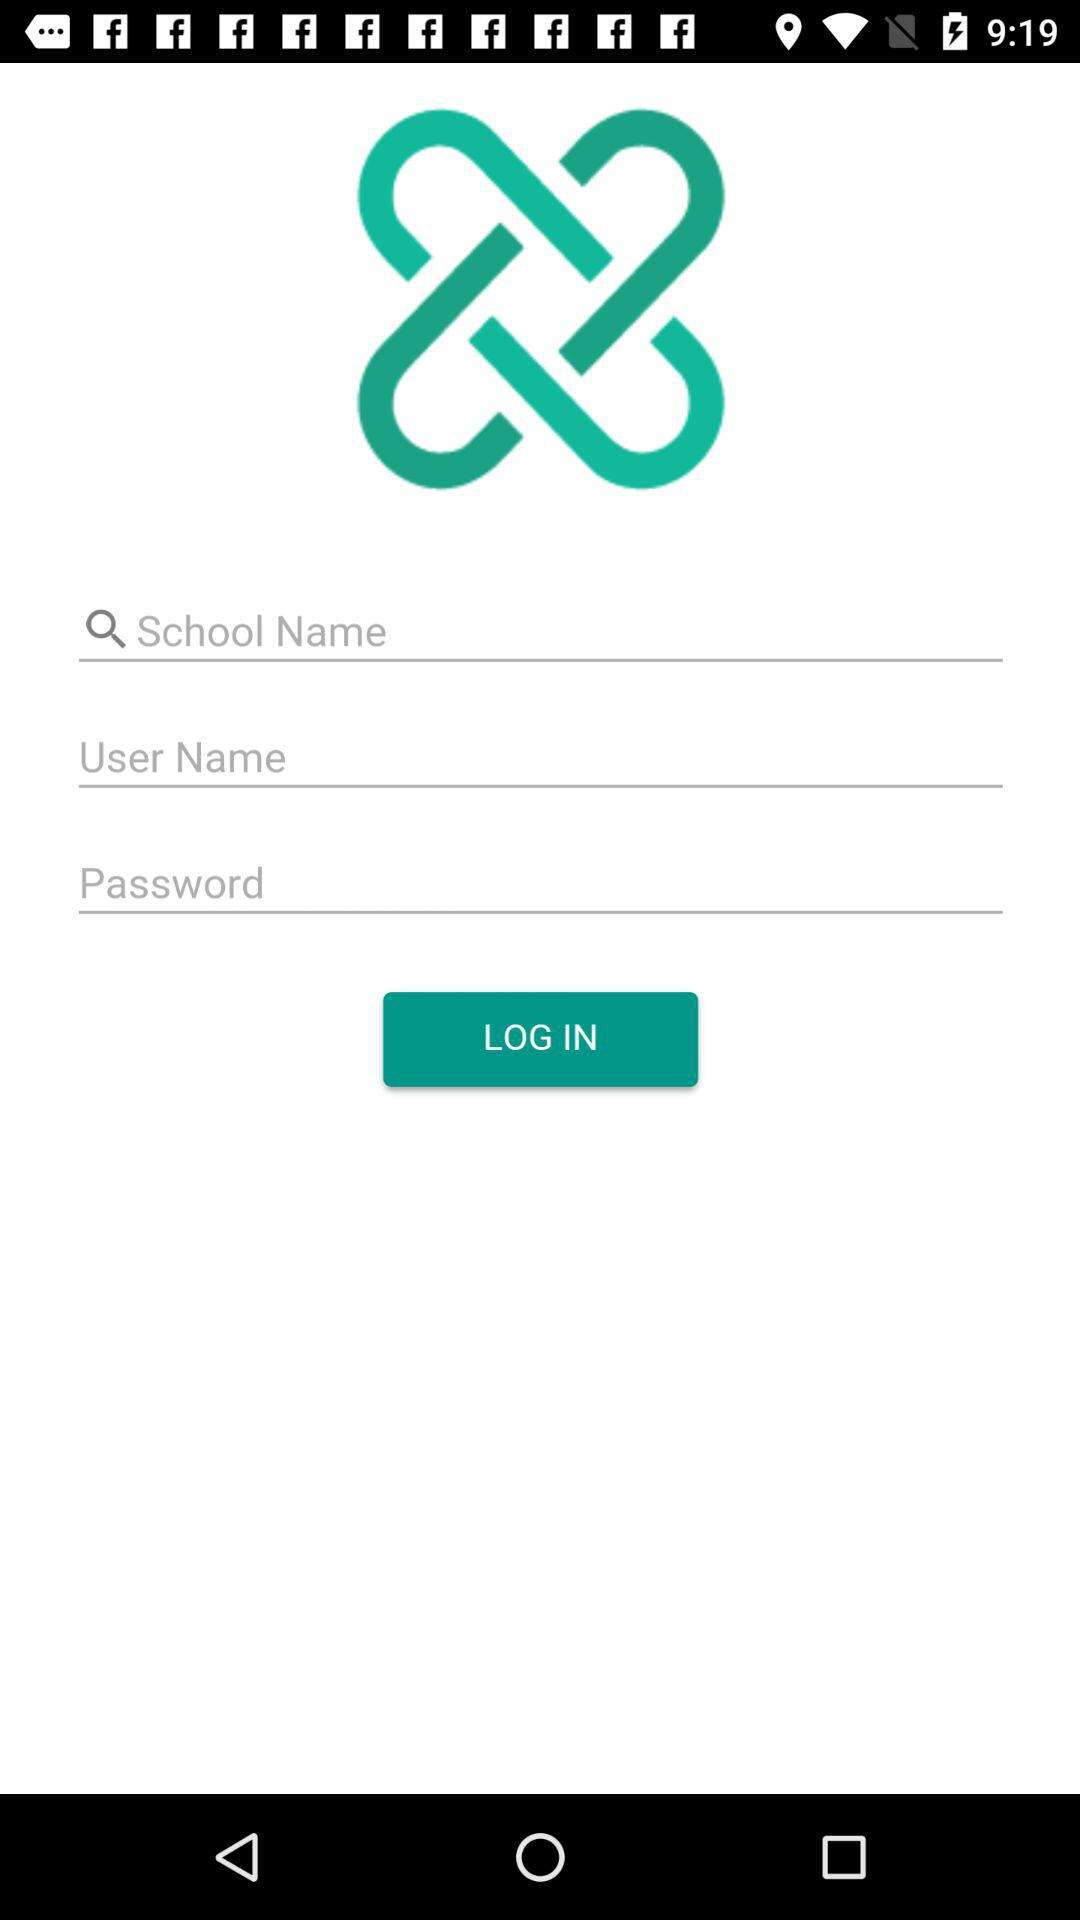How many items are there in the login form?
Answer the question using a single word or phrase. 3 